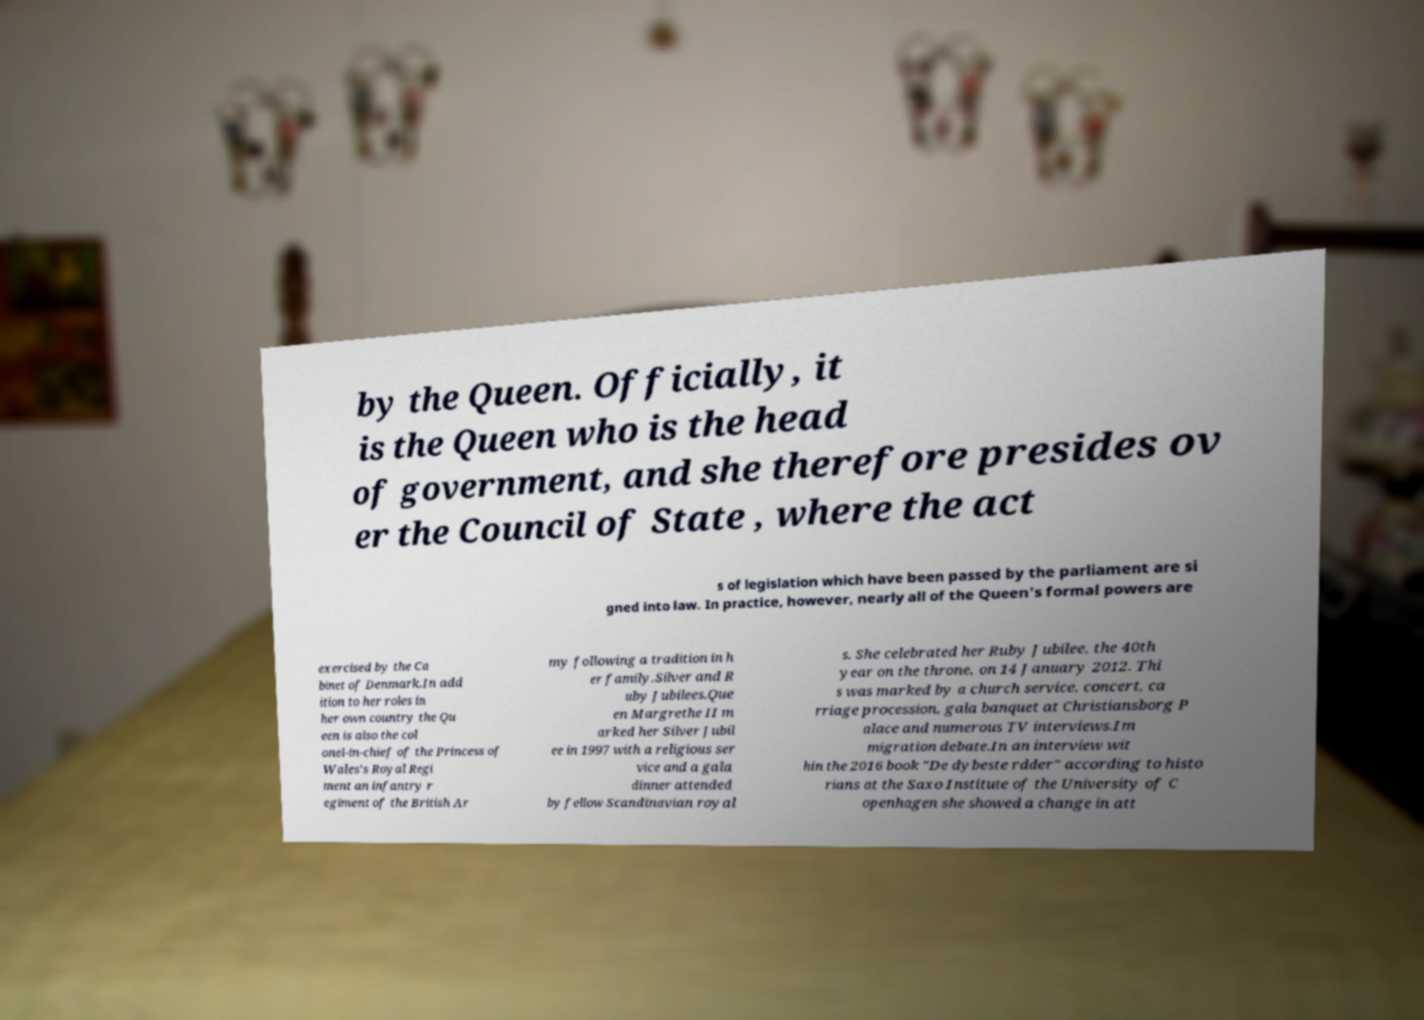Could you assist in decoding the text presented in this image and type it out clearly? by the Queen. Officially, it is the Queen who is the head of government, and she therefore presides ov er the Council of State , where the act s of legislation which have been passed by the parliament are si gned into law. In practice, however, nearly all of the Queen's formal powers are exercised by the Ca binet of Denmark.In add ition to her roles in her own country the Qu een is also the col onel-in-chief of the Princess of Wales's Royal Regi ment an infantry r egiment of the British Ar my following a tradition in h er family.Silver and R uby Jubilees.Que en Margrethe II m arked her Silver Jubil ee in 1997 with a religious ser vice and a gala dinner attended by fellow Scandinavian royal s. She celebrated her Ruby Jubilee, the 40th year on the throne, on 14 January 2012. Thi s was marked by a church service, concert, ca rriage procession, gala banquet at Christiansborg P alace and numerous TV interviews.Im migration debate.In an interview wit hin the 2016 book "De dybeste rdder" according to histo rians at the Saxo Institute of the University of C openhagen she showed a change in att 